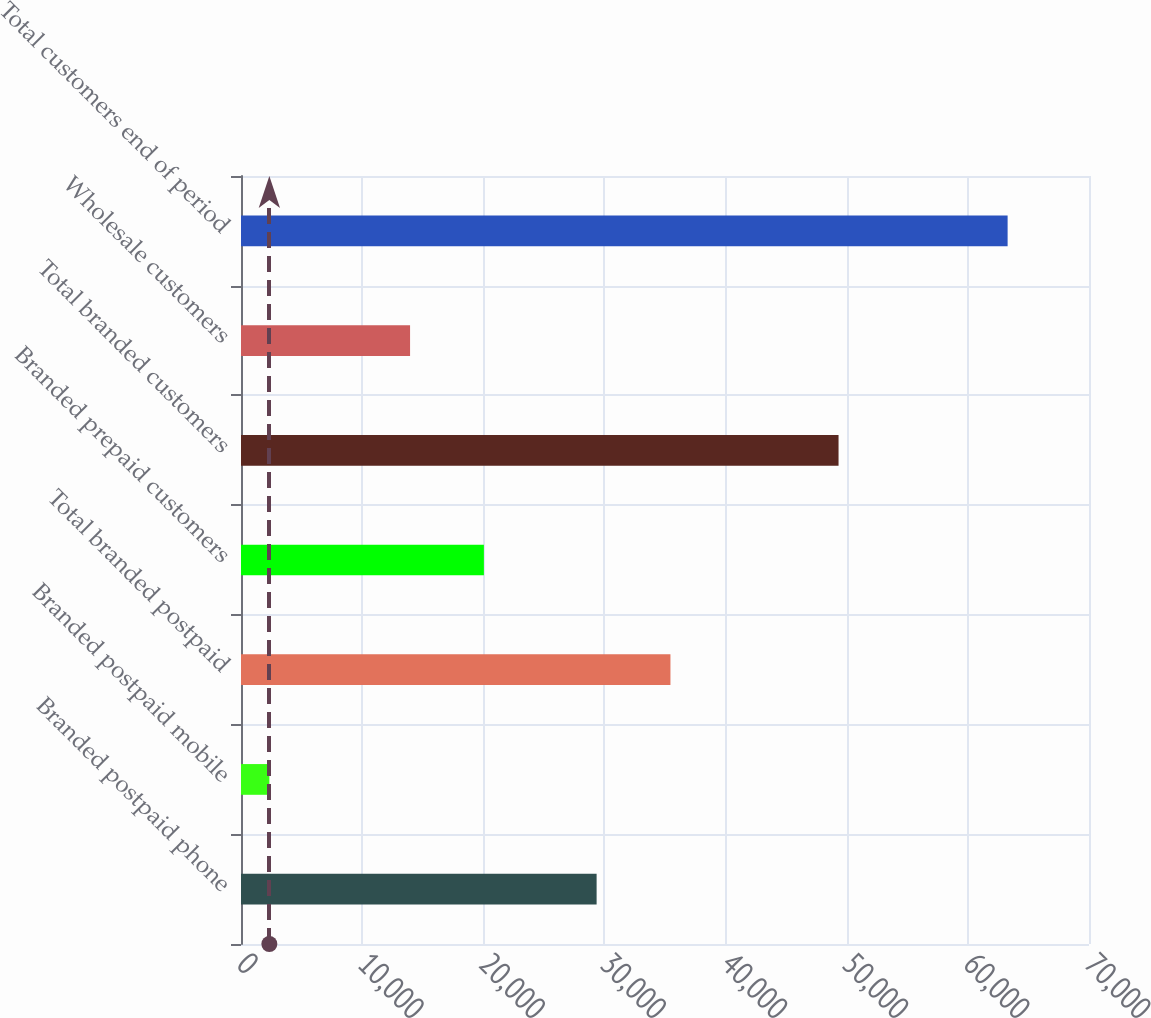Convert chart to OTSL. <chart><loc_0><loc_0><loc_500><loc_500><bar_chart><fcel>Branded postpaid phone<fcel>Branded postpaid mobile<fcel>Total branded postpaid<fcel>Branded prepaid customers<fcel>Total branded customers<fcel>Wholesale customers<fcel>Total customers end of period<nl><fcel>29355<fcel>2340<fcel>35449.2<fcel>20050.2<fcel>49326<fcel>13956<fcel>63282<nl></chart> 